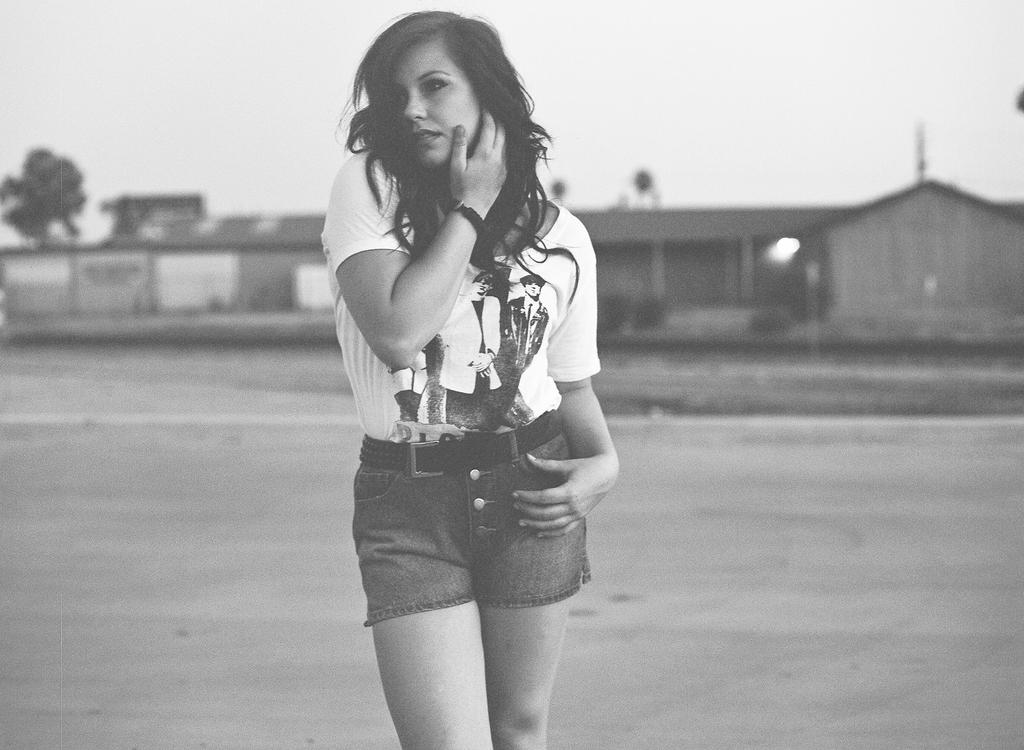What is the color scheme of the image? The image is black and white. Who is present in the image? There is a woman in the image. What can be seen in the background of the image? There is a house, trees, and the sky visible in the background of the image. What type of guide can be seen leading the woman through the thunderstorm in the image? There is no guide or thunderstorm present in the image; it is a black and white image of a woman with a background of a house, trees, and the sky. 